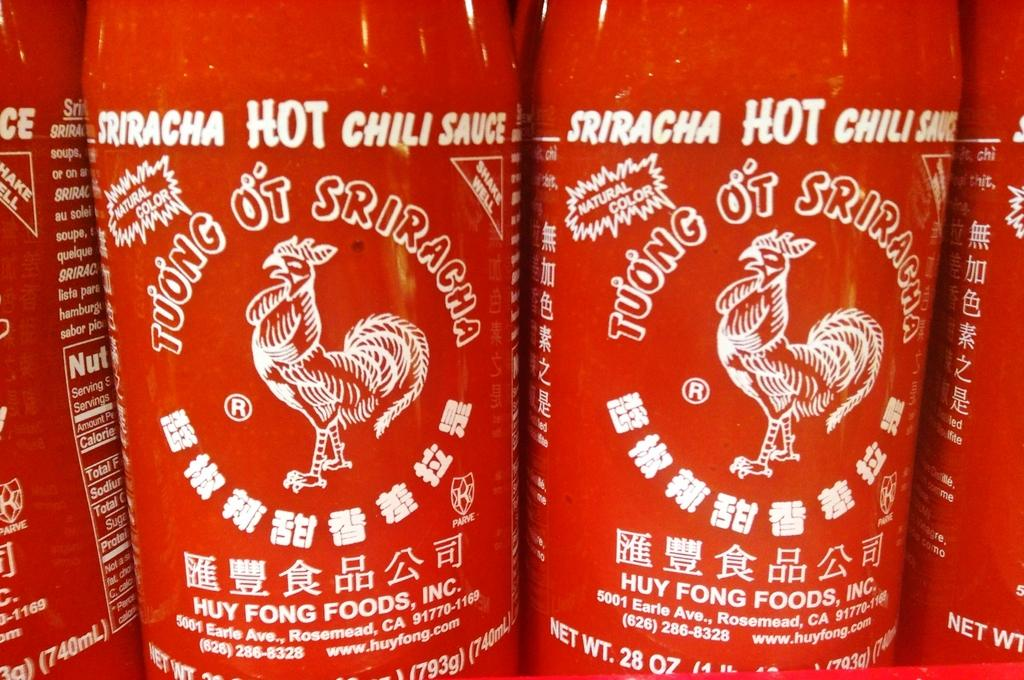Provide a one-sentence caption for the provided image. Red bottles of sriracha sauce are lined up next to each other. 